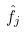<formula> <loc_0><loc_0><loc_500><loc_500>\hat { f _ { j } }</formula> 